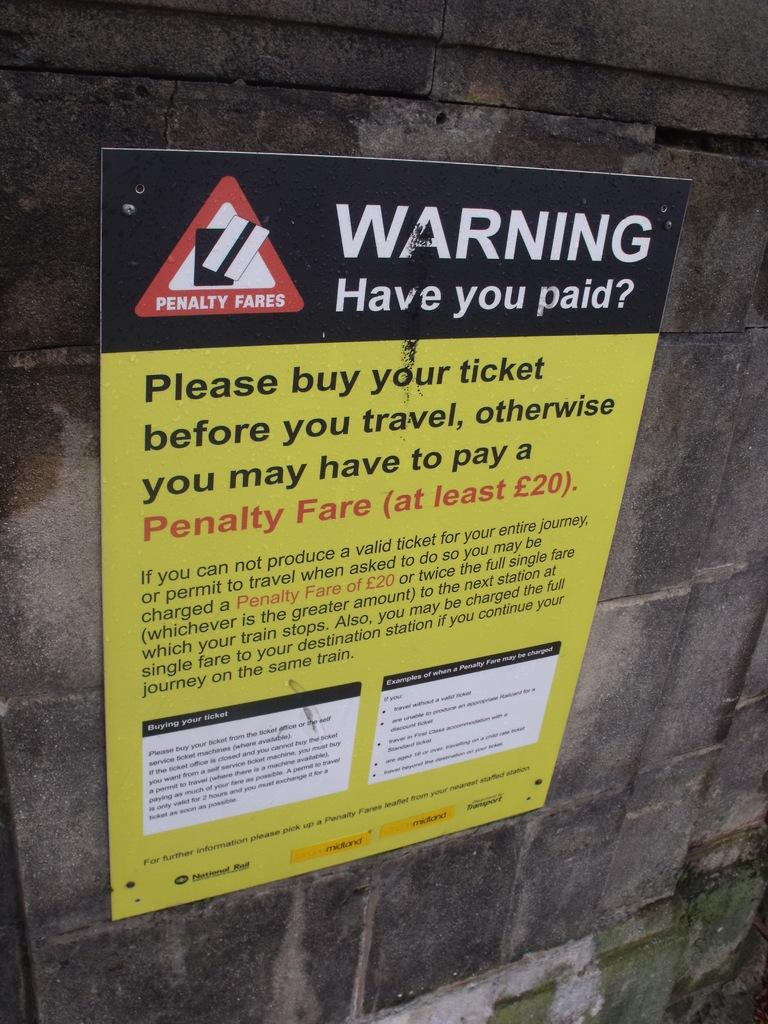<image>
Present a compact description of the photo's key features. A warning sign on your ticket and making sure you buy it before you travel otherwise you might get a penalty fare 